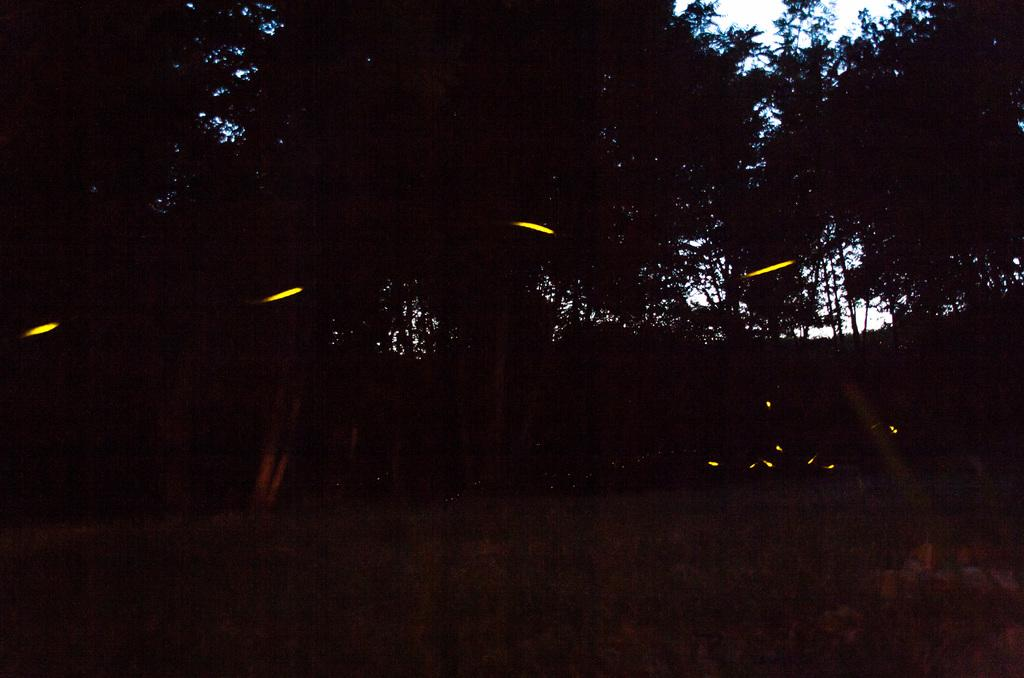What type of vegetation can be seen in the image? There are trees in the image. What else can be seen on the ground in the image? There is grass in the image. What can be seen illuminating the area in the image? There are lights in the image. What is visible in the background of the image? The sky is visible in the image. What color is the crayon being used by the sister in the image? There is no crayon or sister present in the image. 